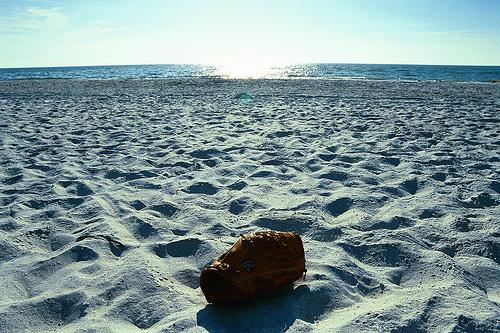Identify the most prominent natural element within this setting and any attended effects of it. The most prominent natural element is the sun, which is creating beautiful reflections on the ocean water and illuminating the scene. Pretend you are a photographer and explain why you might have chosen to take this particular image. I chose to take this image because the baseball glove on the beach creates an intriguing focal point that contrasts with the serene beauty of the natural setting. In a few words, describe the main scenery depicted in the image captured. Beach scene with a baseball glove, sunlit ocean waves, and clear blue sky. Please provide a short description of the main object in the picture and where it is located. A tan leather baseball glove is situated on the sandy beach near the ocean. Consider the image context and give an opinion on whether something is out of place or unusual. Considering the beach setting, the presence of a baseball glove instead of beach equipment like a towel or umbrella is somewhat unusual. What kind of mood or feeling does this image primarily evoke? The image evokes a relaxed and peaceful mood typically associated with a sunny beach day. What is the primary focus of this image? Briefly explain what is happening in the scene. The primary focus is a baseball glove on a sandy beach, with sunlight hitting the ocean waves and creating a beautiful scene of the beach and the water. Can you describe the weather and overall atmosphere within the image? The weather appears to be sunny and clear, with blue skies and an overall bright, pleasant atmosphere. What could be the plausible purpose of capturing this image? Express your thoughts. The purpose could be to showcase the tranquil beauty of the beach, capturing the interesting and unexpected presence of a baseball glove. Explain the possible story or narrative behind the presence of the main object in the image. The baseball glove might belong to someone who brought it to the beach to play catch but left it on the sand while taking a break, adding an element of leisure and fun to the beach scene. Find the red and white logo of the company that made the app. No, it's not mentioned in the image. 